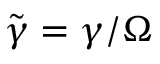Convert formula to latex. <formula><loc_0><loc_0><loc_500><loc_500>\tilde { \gamma } = \gamma / \Omega</formula> 